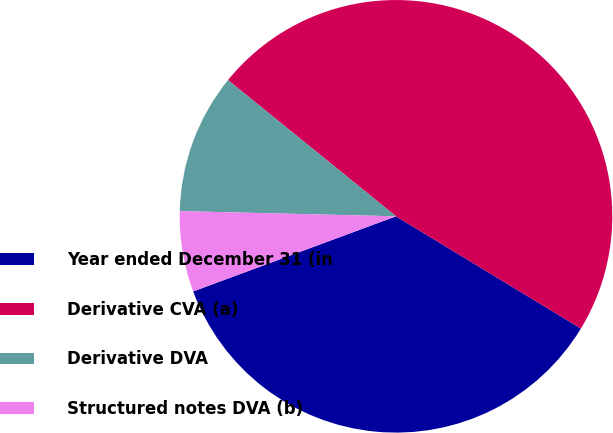<chart> <loc_0><loc_0><loc_500><loc_500><pie_chart><fcel>Year ended December 31 (in<fcel>Derivative CVA (a)<fcel>Derivative DVA<fcel>Structured notes DVA (b)<nl><fcel>35.67%<fcel>47.84%<fcel>10.46%<fcel>6.03%<nl></chart> 